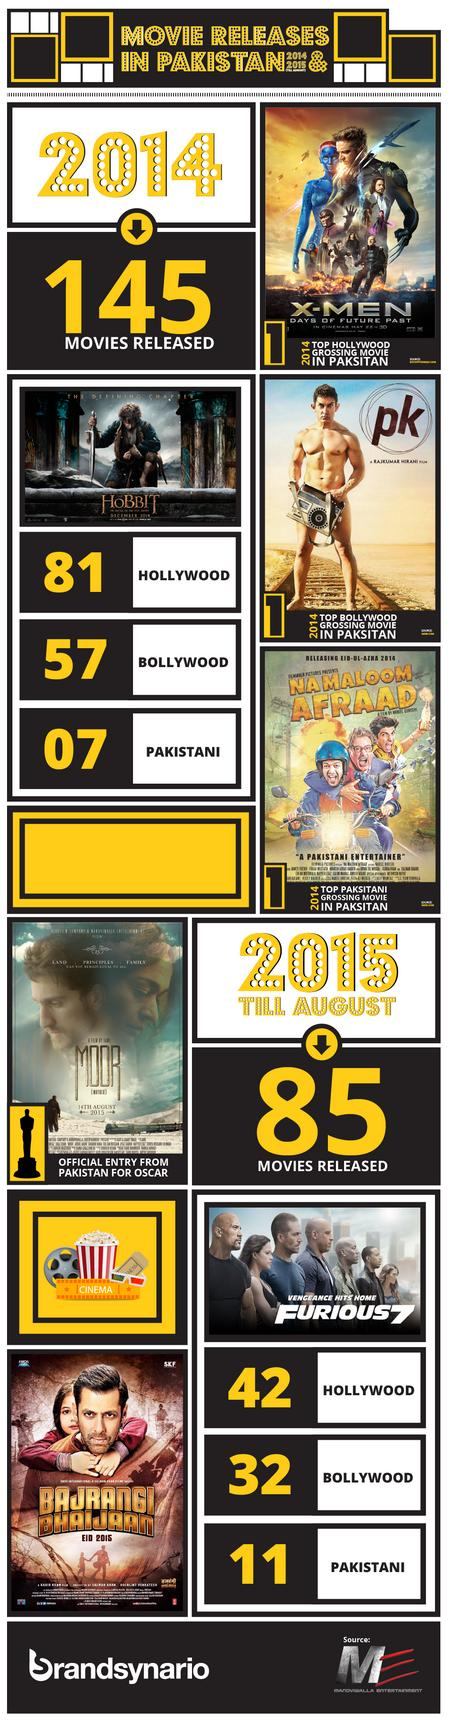Indicate a few pertinent items in this graphic. The infographic mentions 7 movie names. In the years 2014 and 2015, a total of 89 Bollywood movies were released. In the year 2014 and 2015, a total of 123 Hollywood movies were released. The total number of movies released in the years 2014 and 2015, taken together, is 230. In the years 2014 and 2015, a total of 18 Pakistani movies were released. 